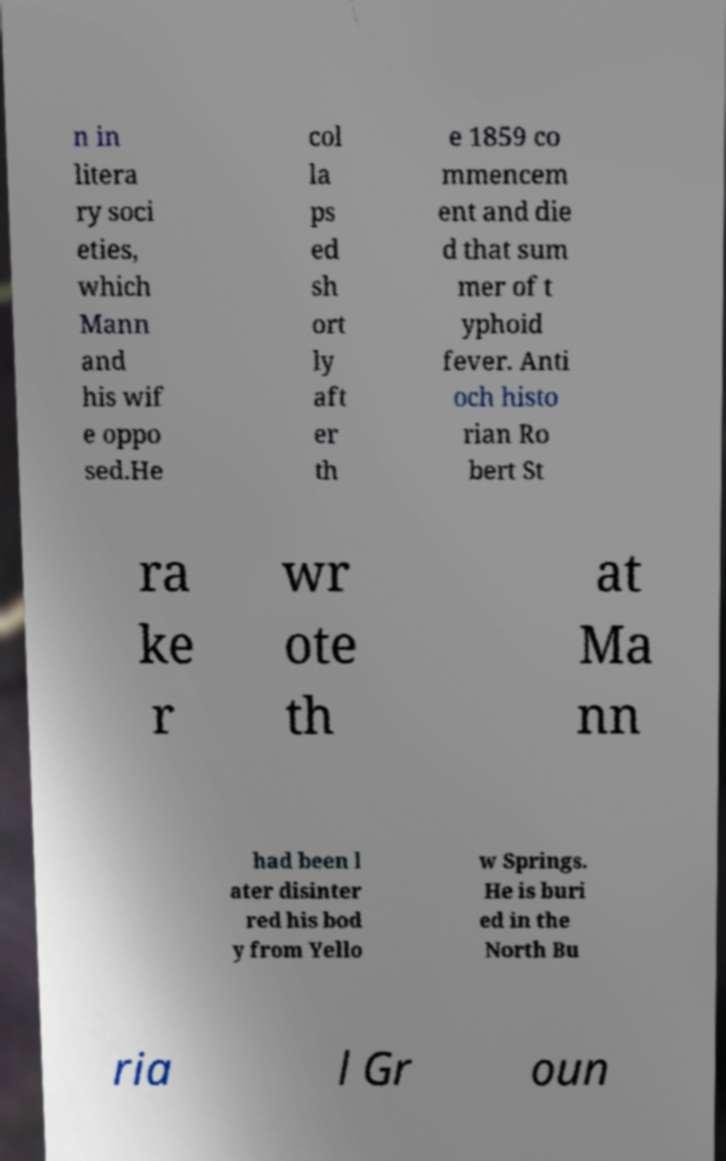For documentation purposes, I need the text within this image transcribed. Could you provide that? n in litera ry soci eties, which Mann and his wif e oppo sed.He col la ps ed sh ort ly aft er th e 1859 co mmencem ent and die d that sum mer of t yphoid fever. Anti och histo rian Ro bert St ra ke r wr ote th at Ma nn had been l ater disinter red his bod y from Yello w Springs. He is buri ed in the North Bu ria l Gr oun 